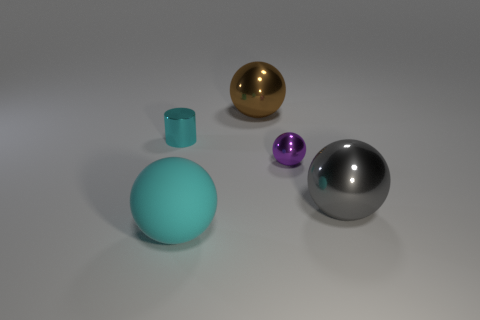Do the large thing on the right side of the small purple object and the cyan object that is on the right side of the small shiny cylinder have the same material?
Keep it short and to the point. No. What material is the gray ball?
Your answer should be very brief. Metal. Is the number of shiny spheres to the right of the small purple metallic thing greater than the number of rubber balls?
Your answer should be compact. No. What number of metal spheres are to the left of the big metal ball in front of the small metal thing that is left of the cyan sphere?
Provide a short and direct response. 2. There is a large thing that is left of the small purple metal thing and in front of the cyan cylinder; what is its material?
Your answer should be very brief. Rubber. What color is the rubber sphere?
Ensure brevity in your answer.  Cyan. Are there more matte objects that are behind the matte object than large gray spheres that are behind the tiny cylinder?
Your response must be concise. No. The large metallic ball to the left of the purple object is what color?
Give a very brief answer. Brown. There is a cyan thing that is left of the large cyan thing; does it have the same size as the purple thing in front of the small cyan cylinder?
Provide a short and direct response. Yes. How many things are large brown spheres or large metallic balls?
Provide a short and direct response. 2. 